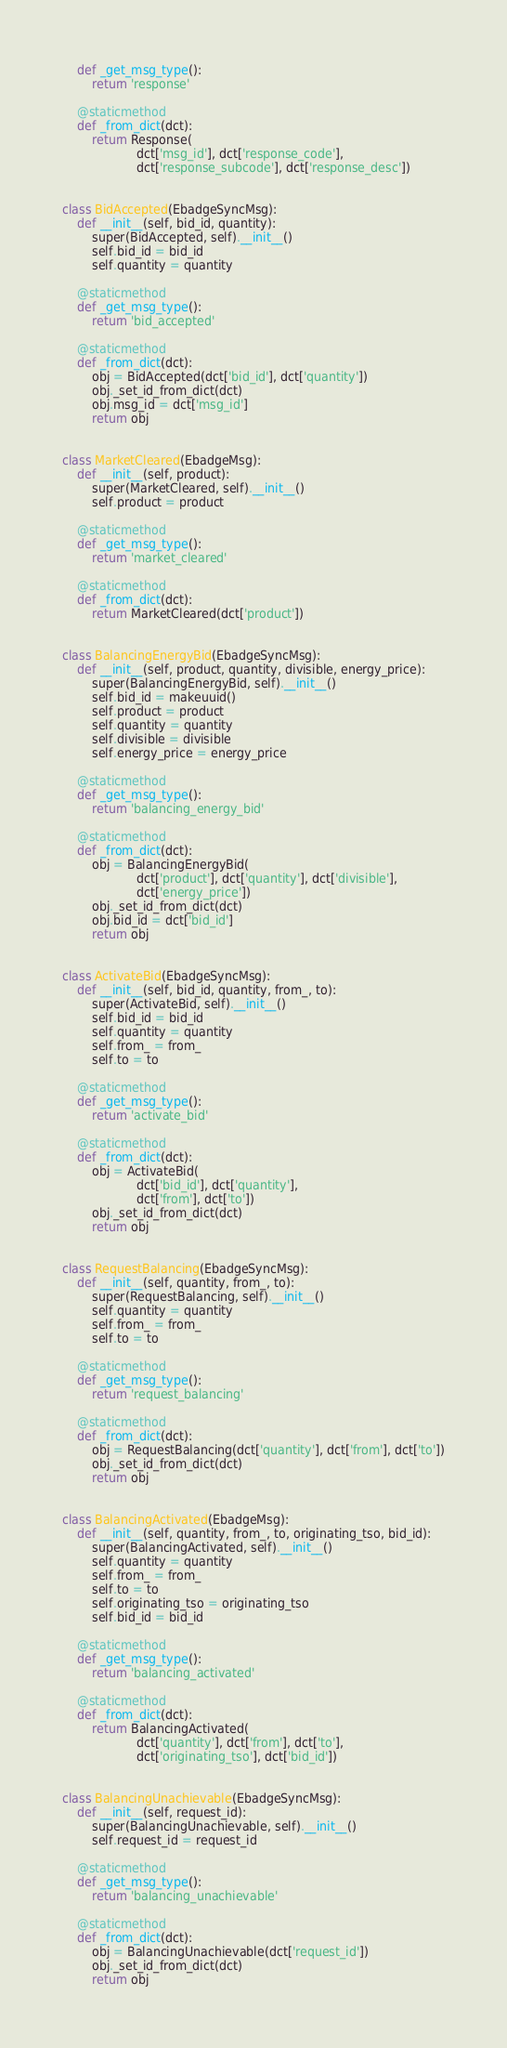Convert code to text. <code><loc_0><loc_0><loc_500><loc_500><_Python_>	def _get_msg_type():
		return 'response'

	@staticmethod
	def _from_dict(dct):
		return Response(
					dct['msg_id'], dct['response_code'],
					dct['response_subcode'], dct['response_desc'])


class BidAccepted(EbadgeSyncMsg):
	def __init__(self, bid_id, quantity):
		super(BidAccepted, self).__init__()
		self.bid_id = bid_id
		self.quantity = quantity

	@staticmethod
	def _get_msg_type():
		return 'bid_accepted'

	@staticmethod
	def _from_dict(dct):
		obj = BidAccepted(dct['bid_id'], dct['quantity'])
		obj._set_id_from_dict(dct)
		obj.msg_id = dct['msg_id']
		return obj


class MarketCleared(EbadgeMsg):
	def __init__(self, product):
		super(MarketCleared, self).__init__()
		self.product = product

	@staticmethod
	def _get_msg_type():
		return 'market_cleared'

	@staticmethod
	def _from_dict(dct):
		return MarketCleared(dct['product'])
		

class BalancingEnergyBid(EbadgeSyncMsg):
	def __init__(self, product, quantity, divisible, energy_price):
		super(BalancingEnergyBid, self).__init__()
		self.bid_id = makeuuid()
		self.product = product
		self.quantity = quantity
		self.divisible = divisible
		self.energy_price = energy_price

	@staticmethod
	def _get_msg_type():
		return 'balancing_energy_bid'

	@staticmethod
	def _from_dict(dct):
		obj = BalancingEnergyBid(
					dct['product'], dct['quantity'], dct['divisible'],
					dct['energy_price'])
		obj._set_id_from_dict(dct)
		obj.bid_id = dct['bid_id']
		return obj


class ActivateBid(EbadgeSyncMsg):
	def __init__(self, bid_id, quantity, from_, to):
		super(ActivateBid, self).__init__()
		self.bid_id = bid_id
		self.quantity = quantity
		self.from_ = from_
		self.to = to

	@staticmethod
	def _get_msg_type():
		return 'activate_bid'

	@staticmethod
	def _from_dict(dct):
		obj = ActivateBid(
					dct['bid_id'], dct['quantity'],
					dct['from'], dct['to'])
		obj._set_id_from_dict(dct)
		return obj


class RequestBalancing(EbadgeSyncMsg):
	def __init__(self, quantity, from_, to):
		super(RequestBalancing, self).__init__()
		self.quantity = quantity
		self.from_ = from_
		self.to = to
		
	@staticmethod
	def _get_msg_type():
		return 'request_balancing'

	@staticmethod
	def _from_dict(dct):
		obj = RequestBalancing(dct['quantity'], dct['from'], dct['to'])
		obj._set_id_from_dict(dct)
		return obj


class BalancingActivated(EbadgeMsg):
	def __init__(self, quantity, from_, to, originating_tso, bid_id):
		super(BalancingActivated, self).__init__()
		self.quantity = quantity
		self.from_ = from_
		self.to = to
		self.originating_tso = originating_tso
		self.bid_id = bid_id

	@staticmethod
	def _get_msg_type():
		return 'balancing_activated'

	@staticmethod
	def _from_dict(dct):
		return BalancingActivated(
					dct['quantity'], dct['from'], dct['to'],
					dct['originating_tso'], dct['bid_id'])
		

class BalancingUnachievable(EbadgeSyncMsg):
	def __init__(self, request_id):
		super(BalancingUnachievable, self).__init__()
		self.request_id = request_id

	@staticmethod
	def _get_msg_type():
		return 'balancing_unachievable'
	
	@staticmethod
	def _from_dict(dct):
		obj = BalancingUnachievable(dct['request_id'])
		obj._set_id_from_dict(dct)
		return obj

</code> 